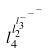Convert formula to latex. <formula><loc_0><loc_0><loc_500><loc_500>l _ { 4 } ^ { l _ { 2 } ^ { l _ { 3 } ^ { - ^ { - ^ { - } } } } }</formula> 